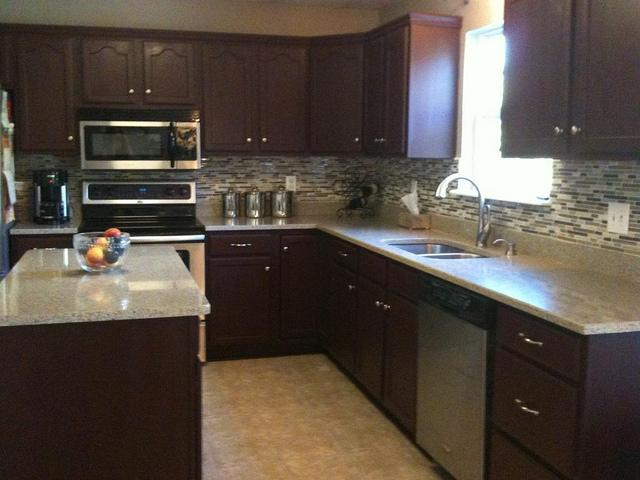The glare from the sun may interfere with a persons ability to do what while cooking? see 